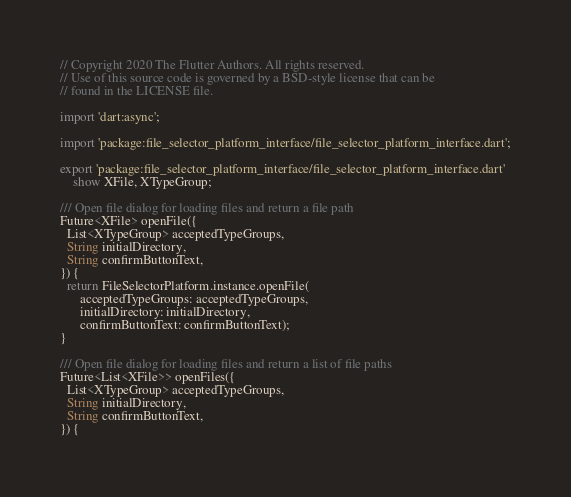<code> <loc_0><loc_0><loc_500><loc_500><_Dart_>// Copyright 2020 The Flutter Authors. All rights reserved.
// Use of this source code is governed by a BSD-style license that can be
// found in the LICENSE file.

import 'dart:async';

import 'package:file_selector_platform_interface/file_selector_platform_interface.dart';

export 'package:file_selector_platform_interface/file_selector_platform_interface.dart'
    show XFile, XTypeGroup;

/// Open file dialog for loading files and return a file path
Future<XFile> openFile({
  List<XTypeGroup> acceptedTypeGroups,
  String initialDirectory,
  String confirmButtonText,
}) {
  return FileSelectorPlatform.instance.openFile(
      acceptedTypeGroups: acceptedTypeGroups,
      initialDirectory: initialDirectory,
      confirmButtonText: confirmButtonText);
}

/// Open file dialog for loading files and return a list of file paths
Future<List<XFile>> openFiles({
  List<XTypeGroup> acceptedTypeGroups,
  String initialDirectory,
  String confirmButtonText,
}) {</code> 